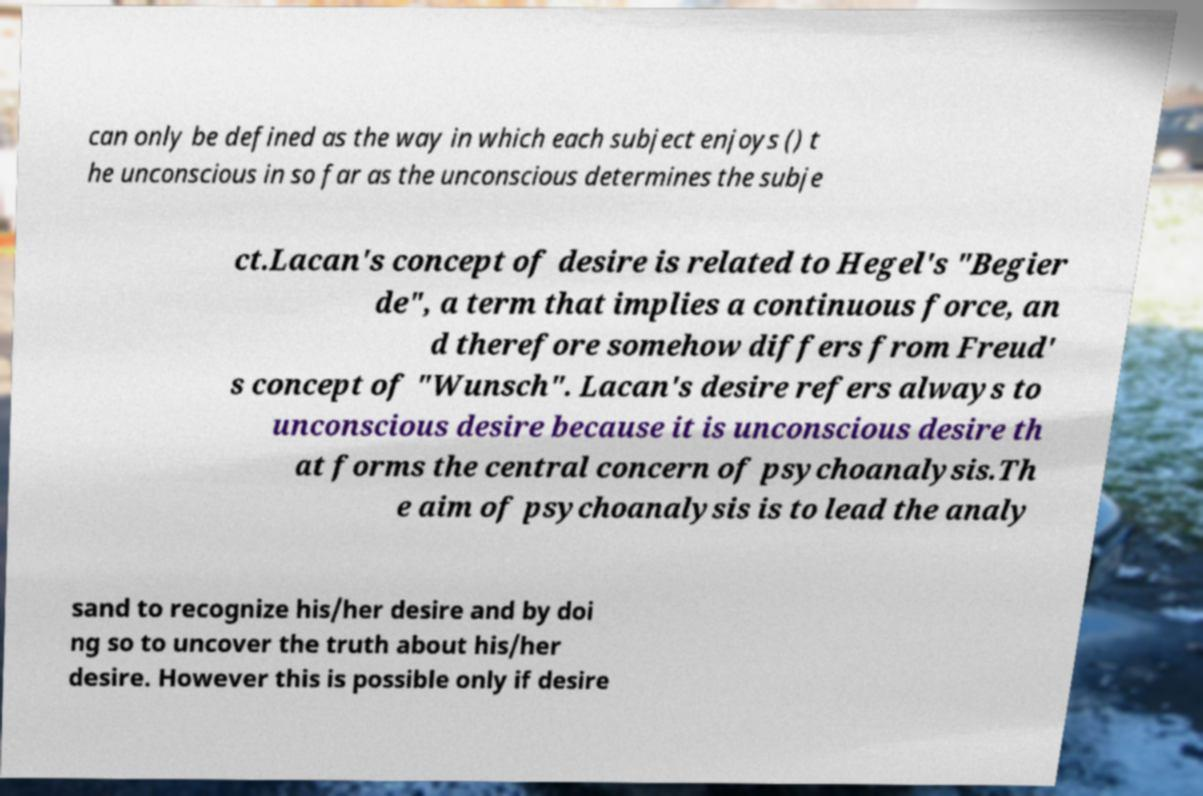Could you extract and type out the text from this image? can only be defined as the way in which each subject enjoys () t he unconscious in so far as the unconscious determines the subje ct.Lacan's concept of desire is related to Hegel's "Begier de", a term that implies a continuous force, an d therefore somehow differs from Freud' s concept of "Wunsch". Lacan's desire refers always to unconscious desire because it is unconscious desire th at forms the central concern of psychoanalysis.Th e aim of psychoanalysis is to lead the analy sand to recognize his/her desire and by doi ng so to uncover the truth about his/her desire. However this is possible only if desire 